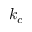Convert formula to latex. <formula><loc_0><loc_0><loc_500><loc_500>k _ { c }</formula> 